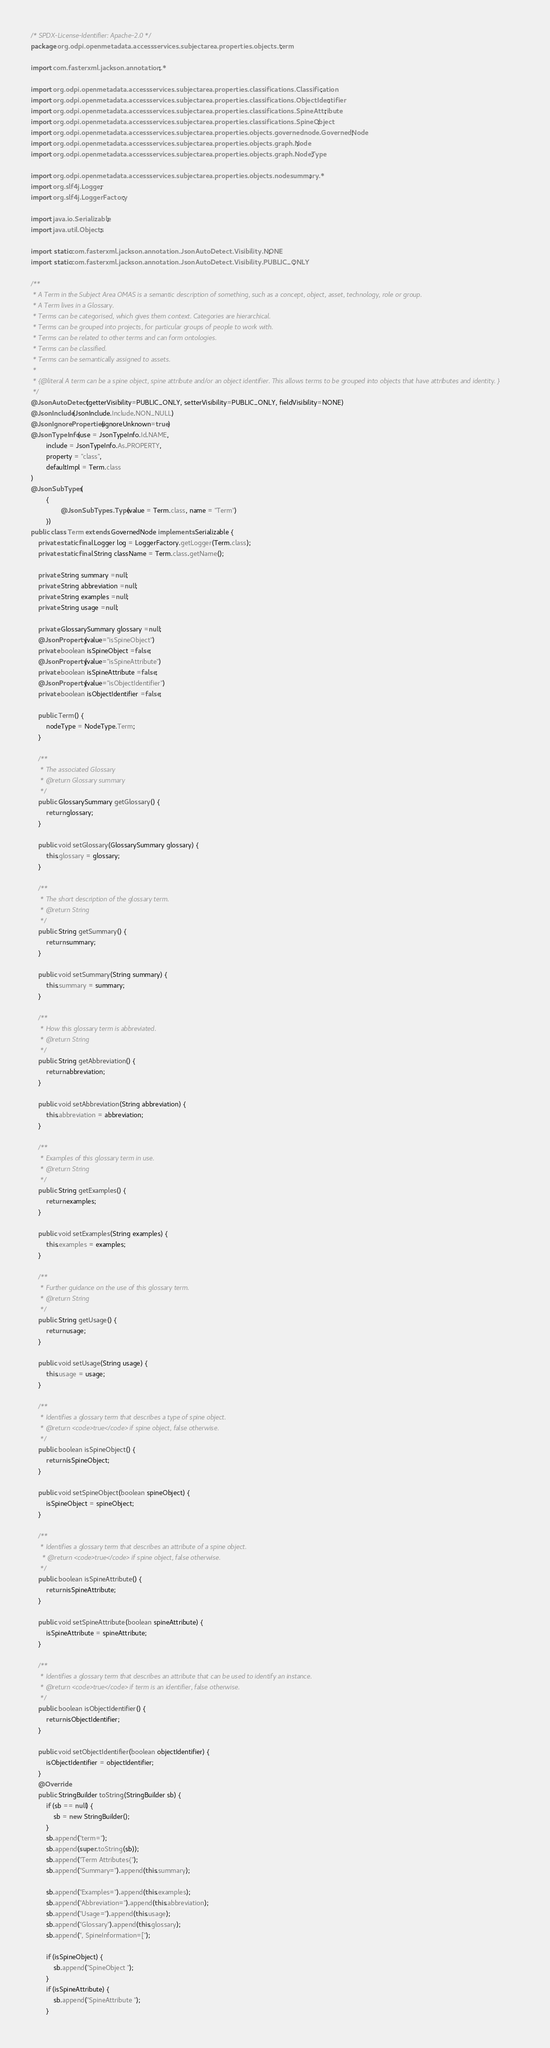<code> <loc_0><loc_0><loc_500><loc_500><_Java_>/* SPDX-License-Identifier: Apache-2.0 */
package org.odpi.openmetadata.accessservices.subjectarea.properties.objects.term;

import com.fasterxml.jackson.annotation.*;

import org.odpi.openmetadata.accessservices.subjectarea.properties.classifications.Classification;
import org.odpi.openmetadata.accessservices.subjectarea.properties.classifications.ObjectIdentifier;
import org.odpi.openmetadata.accessservices.subjectarea.properties.classifications.SpineAttribute;
import org.odpi.openmetadata.accessservices.subjectarea.properties.classifications.SpineObject;
import org.odpi.openmetadata.accessservices.subjectarea.properties.objects.governednode.GovernedNode;
import org.odpi.openmetadata.accessservices.subjectarea.properties.objects.graph.Node;
import org.odpi.openmetadata.accessservices.subjectarea.properties.objects.graph.NodeType;

import org.odpi.openmetadata.accessservices.subjectarea.properties.objects.nodesummary.*;
import org.slf4j.Logger;
import org.slf4j.LoggerFactory;

import java.io.Serializable;
import java.util.Objects;

import static com.fasterxml.jackson.annotation.JsonAutoDetect.Visibility.NONE;
import static com.fasterxml.jackson.annotation.JsonAutoDetect.Visibility.PUBLIC_ONLY;

/**
 * A Term in the Subject Area OMAS is a semantic description of something, such as a concept, object, asset, technology, role or group.
 * A Term lives in a Glossary.
 * Terms can be categorised, which gives them context. Categories are hierarchical.
 * Terms can be grouped into projects, for particular groups of people to work with.
 * Terms can be related to other terms and can form ontologies.
 * Terms can be classified.
 * Terms can be semantically assigned to assets.
 *
 * {@literal A term can be a spine object, spine attribute and/or an object identifier. This allows terms to be grouped into objects that have attributes and identity. }
 */
@JsonAutoDetect(getterVisibility=PUBLIC_ONLY, setterVisibility=PUBLIC_ONLY, fieldVisibility=NONE)
@JsonInclude(JsonInclude.Include.NON_NULL)
@JsonIgnoreProperties(ignoreUnknown=true)
@JsonTypeInfo(use = JsonTypeInfo.Id.NAME,
        include = JsonTypeInfo.As.PROPERTY,
        property = "class",
        defaultImpl = Term.class
)
@JsonSubTypes(
        {
                @JsonSubTypes.Type(value = Term.class, name = "Term")
        })
public class Term extends GovernedNode implements Serializable {
    private static final Logger log = LoggerFactory.getLogger(Term.class);
    private static final String className = Term.class.getName();

    private String summary =null;
    private String abbreviation =null;
    private String examples =null;
    private String usage =null;

    private GlossarySummary glossary =null;
    @JsonProperty(value="isSpineObject")
    private boolean isSpineObject =false;
    @JsonProperty(value="isSpineAttribute")
    private boolean isSpineAttribute =false;
    @JsonProperty(value="isObjectIdentifier")
    private boolean isObjectIdentifier =false;

    public Term() {
        nodeType = NodeType.Term;
    }

    /**
     * The associated Glossary
     * @return Glossary summary
     */
    public GlossarySummary getGlossary() {
        return glossary;
    }

    public void setGlossary(GlossarySummary glossary) {
        this.glossary = glossary;
    }

    /**
     * The short description of the glossary term.
     * @return String
     */
    public String getSummary() {
        return summary;
    }

    public void setSummary(String summary) {
        this.summary = summary;
    }

    /**
     * How this glossary term is abbreviated.
     * @return String
     */
    public String getAbbreviation() {
        return abbreviation;
    }

    public void setAbbreviation(String abbreviation) {
        this.abbreviation = abbreviation;
    }

    /**
     * Examples of this glossary term in use.
     * @return String
     */
    public String getExamples() {
        return examples;
    }

    public void setExamples(String examples) {
        this.examples = examples;
    }

    /**
     * Further guidance on the use of this glossary term.
     * @return String
     */
    public String getUsage() {
        return usage;
    }

    public void setUsage(String usage) {
        this.usage = usage;
    }

    /**
     * Identifies a glossary term that describes a type of spine object.
     * @return <code>true</code> if spine object, false otherwise.
     */
    public boolean isSpineObject() {
        return isSpineObject;
    }

    public void setSpineObject(boolean spineObject) {
        isSpineObject = spineObject;
    }

    /**
     * Identifies a glossary term that describes an attribute of a spine object.
      * @return <code>true</code> if spine object, false otherwise.
     */
    public boolean isSpineAttribute() {
        return isSpineAttribute;
    }

    public void setSpineAttribute(boolean spineAttribute) {
        isSpineAttribute = spineAttribute;
    }

    /**
     * Identifies a glossary term that describes an attribute that can be used to identify an instance.
     * @return <code>true</code> if term is an identifier, false otherwise.
     */
    public boolean isObjectIdentifier() {
        return isObjectIdentifier;
    }

    public void setObjectIdentifier(boolean objectIdentifier) {
        isObjectIdentifier = objectIdentifier;
    }
    @Override
    public StringBuilder toString(StringBuilder sb) {
        if (sb == null) {
            sb = new StringBuilder();
        }
        sb.append("term=");
        sb.append(super.toString(sb));
        sb.append("Term Attributes{");
        sb.append("Summary=").append(this.summary);

        sb.append("Examples=").append(this.examples);
        sb.append("Abbreviation=").append(this.abbreviation);
        sb.append("Usage=").append(this.usage);
        sb.append("Glossary").append(this.glossary);
        sb.append(", SpineInformation=[");

        if (isSpineObject) {
            sb.append("SpineObject ");
        }
        if (isSpineAttribute) {
            sb.append("SpineAttribute ");
        }</code> 